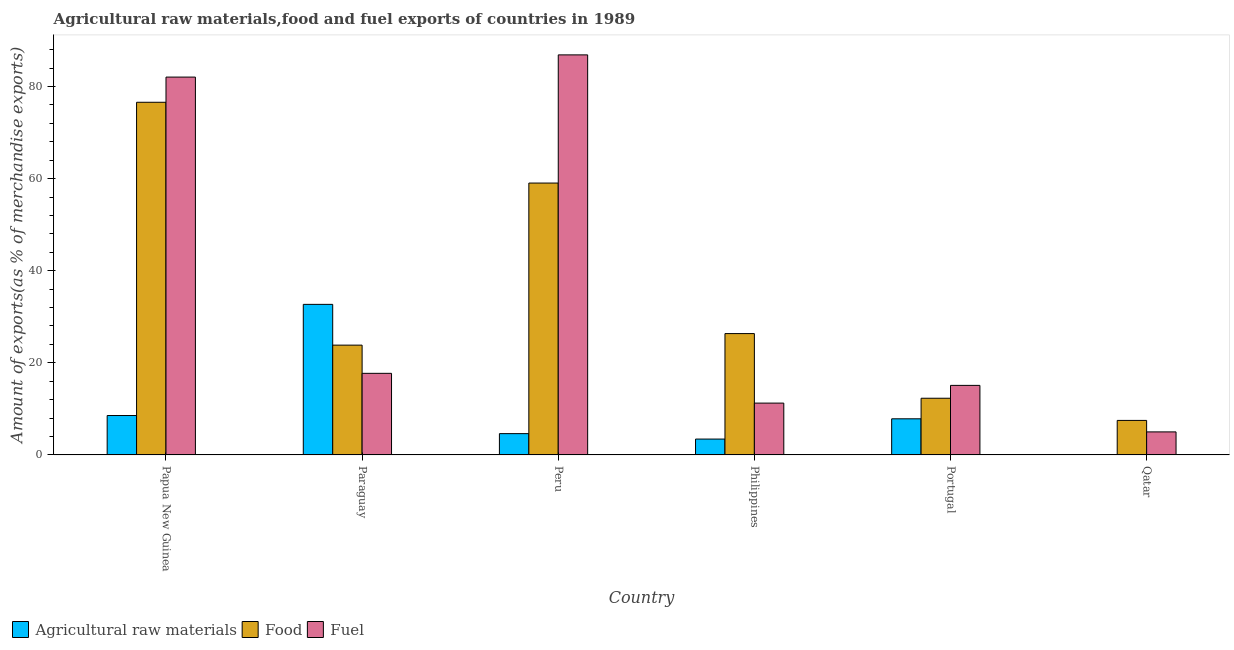How many different coloured bars are there?
Ensure brevity in your answer.  3. Are the number of bars per tick equal to the number of legend labels?
Offer a terse response. Yes. How many bars are there on the 2nd tick from the right?
Your answer should be very brief. 3. What is the label of the 1st group of bars from the left?
Your answer should be compact. Papua New Guinea. In how many cases, is the number of bars for a given country not equal to the number of legend labels?
Your answer should be compact. 0. What is the percentage of food exports in Peru?
Your answer should be compact. 59.04. Across all countries, what is the maximum percentage of food exports?
Give a very brief answer. 76.58. Across all countries, what is the minimum percentage of raw materials exports?
Make the answer very short. 0.07. In which country was the percentage of fuel exports maximum?
Your answer should be compact. Peru. In which country was the percentage of food exports minimum?
Give a very brief answer. Qatar. What is the total percentage of fuel exports in the graph?
Your answer should be very brief. 217.99. What is the difference between the percentage of raw materials exports in Peru and that in Qatar?
Keep it short and to the point. 4.55. What is the difference between the percentage of raw materials exports in Qatar and the percentage of food exports in Papua New Guinea?
Make the answer very short. -76.51. What is the average percentage of fuel exports per country?
Provide a succinct answer. 36.33. What is the difference between the percentage of raw materials exports and percentage of fuel exports in Paraguay?
Provide a succinct answer. 14.98. In how many countries, is the percentage of fuel exports greater than 80 %?
Your response must be concise. 2. What is the ratio of the percentage of fuel exports in Papua New Guinea to that in Philippines?
Provide a short and direct response. 7.29. Is the percentage of fuel exports in Peru less than that in Qatar?
Provide a short and direct response. No. Is the difference between the percentage of food exports in Papua New Guinea and Peru greater than the difference between the percentage of raw materials exports in Papua New Guinea and Peru?
Keep it short and to the point. Yes. What is the difference between the highest and the second highest percentage of raw materials exports?
Your answer should be compact. 24.14. What is the difference between the highest and the lowest percentage of raw materials exports?
Offer a terse response. 32.62. What does the 1st bar from the left in Peru represents?
Ensure brevity in your answer.  Agricultural raw materials. What does the 3rd bar from the right in Qatar represents?
Your answer should be compact. Agricultural raw materials. Is it the case that in every country, the sum of the percentage of raw materials exports and percentage of food exports is greater than the percentage of fuel exports?
Your response must be concise. No. Are all the bars in the graph horizontal?
Provide a succinct answer. No. How many countries are there in the graph?
Give a very brief answer. 6. Does the graph contain grids?
Your response must be concise. No. How many legend labels are there?
Ensure brevity in your answer.  3. How are the legend labels stacked?
Your answer should be very brief. Horizontal. What is the title of the graph?
Your response must be concise. Agricultural raw materials,food and fuel exports of countries in 1989. Does "Neonatal" appear as one of the legend labels in the graph?
Your answer should be very brief. No. What is the label or title of the Y-axis?
Provide a short and direct response. Amount of exports(as % of merchandise exports). What is the Amount of exports(as % of merchandise exports) in Agricultural raw materials in Papua New Guinea?
Offer a very short reply. 8.56. What is the Amount of exports(as % of merchandise exports) in Food in Papua New Guinea?
Your answer should be very brief. 76.58. What is the Amount of exports(as % of merchandise exports) of Fuel in Papua New Guinea?
Provide a succinct answer. 82.05. What is the Amount of exports(as % of merchandise exports) in Agricultural raw materials in Paraguay?
Your response must be concise. 32.69. What is the Amount of exports(as % of merchandise exports) of Food in Paraguay?
Your response must be concise. 23.84. What is the Amount of exports(as % of merchandise exports) in Fuel in Paraguay?
Offer a terse response. 17.72. What is the Amount of exports(as % of merchandise exports) in Agricultural raw materials in Peru?
Offer a terse response. 4.63. What is the Amount of exports(as % of merchandise exports) in Food in Peru?
Provide a succinct answer. 59.04. What is the Amount of exports(as % of merchandise exports) in Fuel in Peru?
Ensure brevity in your answer.  86.87. What is the Amount of exports(as % of merchandise exports) in Agricultural raw materials in Philippines?
Give a very brief answer. 3.44. What is the Amount of exports(as % of merchandise exports) in Food in Philippines?
Your answer should be compact. 26.35. What is the Amount of exports(as % of merchandise exports) in Fuel in Philippines?
Your response must be concise. 11.25. What is the Amount of exports(as % of merchandise exports) of Agricultural raw materials in Portugal?
Keep it short and to the point. 7.85. What is the Amount of exports(as % of merchandise exports) in Food in Portugal?
Ensure brevity in your answer.  12.31. What is the Amount of exports(as % of merchandise exports) of Fuel in Portugal?
Your answer should be compact. 15.1. What is the Amount of exports(as % of merchandise exports) of Agricultural raw materials in Qatar?
Offer a terse response. 0.07. What is the Amount of exports(as % of merchandise exports) in Food in Qatar?
Offer a very short reply. 7.5. What is the Amount of exports(as % of merchandise exports) in Fuel in Qatar?
Give a very brief answer. 5. Across all countries, what is the maximum Amount of exports(as % of merchandise exports) of Agricultural raw materials?
Keep it short and to the point. 32.69. Across all countries, what is the maximum Amount of exports(as % of merchandise exports) of Food?
Provide a succinct answer. 76.58. Across all countries, what is the maximum Amount of exports(as % of merchandise exports) of Fuel?
Ensure brevity in your answer.  86.87. Across all countries, what is the minimum Amount of exports(as % of merchandise exports) in Agricultural raw materials?
Offer a terse response. 0.07. Across all countries, what is the minimum Amount of exports(as % of merchandise exports) in Food?
Keep it short and to the point. 7.5. Across all countries, what is the minimum Amount of exports(as % of merchandise exports) in Fuel?
Offer a very short reply. 5. What is the total Amount of exports(as % of merchandise exports) in Agricultural raw materials in the graph?
Your response must be concise. 57.24. What is the total Amount of exports(as % of merchandise exports) of Food in the graph?
Your answer should be compact. 205.62. What is the total Amount of exports(as % of merchandise exports) in Fuel in the graph?
Provide a succinct answer. 217.99. What is the difference between the Amount of exports(as % of merchandise exports) of Agricultural raw materials in Papua New Guinea and that in Paraguay?
Your answer should be very brief. -24.14. What is the difference between the Amount of exports(as % of merchandise exports) of Food in Papua New Guinea and that in Paraguay?
Your answer should be compact. 52.73. What is the difference between the Amount of exports(as % of merchandise exports) in Fuel in Papua New Guinea and that in Paraguay?
Offer a terse response. 64.33. What is the difference between the Amount of exports(as % of merchandise exports) in Agricultural raw materials in Papua New Guinea and that in Peru?
Offer a very short reply. 3.93. What is the difference between the Amount of exports(as % of merchandise exports) of Food in Papua New Guinea and that in Peru?
Give a very brief answer. 17.54. What is the difference between the Amount of exports(as % of merchandise exports) in Fuel in Papua New Guinea and that in Peru?
Make the answer very short. -4.82. What is the difference between the Amount of exports(as % of merchandise exports) in Agricultural raw materials in Papua New Guinea and that in Philippines?
Give a very brief answer. 5.11. What is the difference between the Amount of exports(as % of merchandise exports) of Food in Papua New Guinea and that in Philippines?
Your answer should be very brief. 50.23. What is the difference between the Amount of exports(as % of merchandise exports) of Fuel in Papua New Guinea and that in Philippines?
Your response must be concise. 70.79. What is the difference between the Amount of exports(as % of merchandise exports) in Agricultural raw materials in Papua New Guinea and that in Portugal?
Provide a succinct answer. 0.71. What is the difference between the Amount of exports(as % of merchandise exports) in Food in Papua New Guinea and that in Portugal?
Make the answer very short. 64.27. What is the difference between the Amount of exports(as % of merchandise exports) of Fuel in Papua New Guinea and that in Portugal?
Your answer should be very brief. 66.94. What is the difference between the Amount of exports(as % of merchandise exports) in Agricultural raw materials in Papua New Guinea and that in Qatar?
Give a very brief answer. 8.48. What is the difference between the Amount of exports(as % of merchandise exports) of Food in Papua New Guinea and that in Qatar?
Your answer should be very brief. 69.08. What is the difference between the Amount of exports(as % of merchandise exports) in Fuel in Papua New Guinea and that in Qatar?
Give a very brief answer. 77.04. What is the difference between the Amount of exports(as % of merchandise exports) of Agricultural raw materials in Paraguay and that in Peru?
Your answer should be very brief. 28.07. What is the difference between the Amount of exports(as % of merchandise exports) of Food in Paraguay and that in Peru?
Offer a very short reply. -35.19. What is the difference between the Amount of exports(as % of merchandise exports) in Fuel in Paraguay and that in Peru?
Offer a very short reply. -69.15. What is the difference between the Amount of exports(as % of merchandise exports) in Agricultural raw materials in Paraguay and that in Philippines?
Your answer should be very brief. 29.25. What is the difference between the Amount of exports(as % of merchandise exports) in Food in Paraguay and that in Philippines?
Offer a terse response. -2.51. What is the difference between the Amount of exports(as % of merchandise exports) in Fuel in Paraguay and that in Philippines?
Offer a very short reply. 6.46. What is the difference between the Amount of exports(as % of merchandise exports) of Agricultural raw materials in Paraguay and that in Portugal?
Provide a succinct answer. 24.85. What is the difference between the Amount of exports(as % of merchandise exports) in Food in Paraguay and that in Portugal?
Your answer should be compact. 11.53. What is the difference between the Amount of exports(as % of merchandise exports) in Fuel in Paraguay and that in Portugal?
Keep it short and to the point. 2.61. What is the difference between the Amount of exports(as % of merchandise exports) of Agricultural raw materials in Paraguay and that in Qatar?
Give a very brief answer. 32.62. What is the difference between the Amount of exports(as % of merchandise exports) in Food in Paraguay and that in Qatar?
Your answer should be compact. 16.35. What is the difference between the Amount of exports(as % of merchandise exports) of Fuel in Paraguay and that in Qatar?
Your response must be concise. 12.71. What is the difference between the Amount of exports(as % of merchandise exports) of Agricultural raw materials in Peru and that in Philippines?
Your answer should be compact. 1.18. What is the difference between the Amount of exports(as % of merchandise exports) in Food in Peru and that in Philippines?
Offer a terse response. 32.68. What is the difference between the Amount of exports(as % of merchandise exports) in Fuel in Peru and that in Philippines?
Ensure brevity in your answer.  75.62. What is the difference between the Amount of exports(as % of merchandise exports) in Agricultural raw materials in Peru and that in Portugal?
Keep it short and to the point. -3.22. What is the difference between the Amount of exports(as % of merchandise exports) in Food in Peru and that in Portugal?
Keep it short and to the point. 46.73. What is the difference between the Amount of exports(as % of merchandise exports) in Fuel in Peru and that in Portugal?
Provide a short and direct response. 71.77. What is the difference between the Amount of exports(as % of merchandise exports) of Agricultural raw materials in Peru and that in Qatar?
Offer a very short reply. 4.55. What is the difference between the Amount of exports(as % of merchandise exports) in Food in Peru and that in Qatar?
Offer a very short reply. 51.54. What is the difference between the Amount of exports(as % of merchandise exports) of Fuel in Peru and that in Qatar?
Provide a succinct answer. 81.87. What is the difference between the Amount of exports(as % of merchandise exports) of Agricultural raw materials in Philippines and that in Portugal?
Your answer should be compact. -4.4. What is the difference between the Amount of exports(as % of merchandise exports) in Food in Philippines and that in Portugal?
Provide a succinct answer. 14.04. What is the difference between the Amount of exports(as % of merchandise exports) of Fuel in Philippines and that in Portugal?
Provide a short and direct response. -3.85. What is the difference between the Amount of exports(as % of merchandise exports) of Agricultural raw materials in Philippines and that in Qatar?
Your answer should be very brief. 3.37. What is the difference between the Amount of exports(as % of merchandise exports) of Food in Philippines and that in Qatar?
Keep it short and to the point. 18.85. What is the difference between the Amount of exports(as % of merchandise exports) of Fuel in Philippines and that in Qatar?
Offer a very short reply. 6.25. What is the difference between the Amount of exports(as % of merchandise exports) in Agricultural raw materials in Portugal and that in Qatar?
Offer a very short reply. 7.77. What is the difference between the Amount of exports(as % of merchandise exports) in Food in Portugal and that in Qatar?
Your answer should be very brief. 4.81. What is the difference between the Amount of exports(as % of merchandise exports) of Fuel in Portugal and that in Qatar?
Your answer should be compact. 10.1. What is the difference between the Amount of exports(as % of merchandise exports) of Agricultural raw materials in Papua New Guinea and the Amount of exports(as % of merchandise exports) of Food in Paraguay?
Make the answer very short. -15.29. What is the difference between the Amount of exports(as % of merchandise exports) of Agricultural raw materials in Papua New Guinea and the Amount of exports(as % of merchandise exports) of Fuel in Paraguay?
Make the answer very short. -9.16. What is the difference between the Amount of exports(as % of merchandise exports) of Food in Papua New Guinea and the Amount of exports(as % of merchandise exports) of Fuel in Paraguay?
Offer a very short reply. 58.86. What is the difference between the Amount of exports(as % of merchandise exports) in Agricultural raw materials in Papua New Guinea and the Amount of exports(as % of merchandise exports) in Food in Peru?
Ensure brevity in your answer.  -50.48. What is the difference between the Amount of exports(as % of merchandise exports) in Agricultural raw materials in Papua New Guinea and the Amount of exports(as % of merchandise exports) in Fuel in Peru?
Make the answer very short. -78.31. What is the difference between the Amount of exports(as % of merchandise exports) in Food in Papua New Guinea and the Amount of exports(as % of merchandise exports) in Fuel in Peru?
Offer a very short reply. -10.29. What is the difference between the Amount of exports(as % of merchandise exports) in Agricultural raw materials in Papua New Guinea and the Amount of exports(as % of merchandise exports) in Food in Philippines?
Your response must be concise. -17.79. What is the difference between the Amount of exports(as % of merchandise exports) of Agricultural raw materials in Papua New Guinea and the Amount of exports(as % of merchandise exports) of Fuel in Philippines?
Provide a succinct answer. -2.7. What is the difference between the Amount of exports(as % of merchandise exports) of Food in Papua New Guinea and the Amount of exports(as % of merchandise exports) of Fuel in Philippines?
Ensure brevity in your answer.  65.33. What is the difference between the Amount of exports(as % of merchandise exports) of Agricultural raw materials in Papua New Guinea and the Amount of exports(as % of merchandise exports) of Food in Portugal?
Make the answer very short. -3.75. What is the difference between the Amount of exports(as % of merchandise exports) of Agricultural raw materials in Papua New Guinea and the Amount of exports(as % of merchandise exports) of Fuel in Portugal?
Offer a very short reply. -6.55. What is the difference between the Amount of exports(as % of merchandise exports) of Food in Papua New Guinea and the Amount of exports(as % of merchandise exports) of Fuel in Portugal?
Your answer should be compact. 61.48. What is the difference between the Amount of exports(as % of merchandise exports) of Agricultural raw materials in Papua New Guinea and the Amount of exports(as % of merchandise exports) of Food in Qatar?
Offer a very short reply. 1.06. What is the difference between the Amount of exports(as % of merchandise exports) of Agricultural raw materials in Papua New Guinea and the Amount of exports(as % of merchandise exports) of Fuel in Qatar?
Give a very brief answer. 3.55. What is the difference between the Amount of exports(as % of merchandise exports) of Food in Papua New Guinea and the Amount of exports(as % of merchandise exports) of Fuel in Qatar?
Your answer should be compact. 71.58. What is the difference between the Amount of exports(as % of merchandise exports) in Agricultural raw materials in Paraguay and the Amount of exports(as % of merchandise exports) in Food in Peru?
Your answer should be compact. -26.34. What is the difference between the Amount of exports(as % of merchandise exports) of Agricultural raw materials in Paraguay and the Amount of exports(as % of merchandise exports) of Fuel in Peru?
Keep it short and to the point. -54.18. What is the difference between the Amount of exports(as % of merchandise exports) of Food in Paraguay and the Amount of exports(as % of merchandise exports) of Fuel in Peru?
Offer a terse response. -63.03. What is the difference between the Amount of exports(as % of merchandise exports) in Agricultural raw materials in Paraguay and the Amount of exports(as % of merchandise exports) in Food in Philippines?
Keep it short and to the point. 6.34. What is the difference between the Amount of exports(as % of merchandise exports) of Agricultural raw materials in Paraguay and the Amount of exports(as % of merchandise exports) of Fuel in Philippines?
Give a very brief answer. 21.44. What is the difference between the Amount of exports(as % of merchandise exports) in Food in Paraguay and the Amount of exports(as % of merchandise exports) in Fuel in Philippines?
Offer a terse response. 12.59. What is the difference between the Amount of exports(as % of merchandise exports) of Agricultural raw materials in Paraguay and the Amount of exports(as % of merchandise exports) of Food in Portugal?
Make the answer very short. 20.38. What is the difference between the Amount of exports(as % of merchandise exports) in Agricultural raw materials in Paraguay and the Amount of exports(as % of merchandise exports) in Fuel in Portugal?
Your answer should be very brief. 17.59. What is the difference between the Amount of exports(as % of merchandise exports) of Food in Paraguay and the Amount of exports(as % of merchandise exports) of Fuel in Portugal?
Offer a terse response. 8.74. What is the difference between the Amount of exports(as % of merchandise exports) of Agricultural raw materials in Paraguay and the Amount of exports(as % of merchandise exports) of Food in Qatar?
Offer a very short reply. 25.2. What is the difference between the Amount of exports(as % of merchandise exports) in Agricultural raw materials in Paraguay and the Amount of exports(as % of merchandise exports) in Fuel in Qatar?
Provide a succinct answer. 27.69. What is the difference between the Amount of exports(as % of merchandise exports) in Food in Paraguay and the Amount of exports(as % of merchandise exports) in Fuel in Qatar?
Your response must be concise. 18.84. What is the difference between the Amount of exports(as % of merchandise exports) in Agricultural raw materials in Peru and the Amount of exports(as % of merchandise exports) in Food in Philippines?
Your answer should be very brief. -21.73. What is the difference between the Amount of exports(as % of merchandise exports) in Agricultural raw materials in Peru and the Amount of exports(as % of merchandise exports) in Fuel in Philippines?
Provide a succinct answer. -6.63. What is the difference between the Amount of exports(as % of merchandise exports) of Food in Peru and the Amount of exports(as % of merchandise exports) of Fuel in Philippines?
Your answer should be compact. 47.78. What is the difference between the Amount of exports(as % of merchandise exports) of Agricultural raw materials in Peru and the Amount of exports(as % of merchandise exports) of Food in Portugal?
Your answer should be compact. -7.68. What is the difference between the Amount of exports(as % of merchandise exports) in Agricultural raw materials in Peru and the Amount of exports(as % of merchandise exports) in Fuel in Portugal?
Your response must be concise. -10.48. What is the difference between the Amount of exports(as % of merchandise exports) in Food in Peru and the Amount of exports(as % of merchandise exports) in Fuel in Portugal?
Ensure brevity in your answer.  43.93. What is the difference between the Amount of exports(as % of merchandise exports) of Agricultural raw materials in Peru and the Amount of exports(as % of merchandise exports) of Food in Qatar?
Your answer should be very brief. -2.87. What is the difference between the Amount of exports(as % of merchandise exports) of Agricultural raw materials in Peru and the Amount of exports(as % of merchandise exports) of Fuel in Qatar?
Keep it short and to the point. -0.38. What is the difference between the Amount of exports(as % of merchandise exports) of Food in Peru and the Amount of exports(as % of merchandise exports) of Fuel in Qatar?
Offer a very short reply. 54.03. What is the difference between the Amount of exports(as % of merchandise exports) of Agricultural raw materials in Philippines and the Amount of exports(as % of merchandise exports) of Food in Portugal?
Make the answer very short. -8.87. What is the difference between the Amount of exports(as % of merchandise exports) in Agricultural raw materials in Philippines and the Amount of exports(as % of merchandise exports) in Fuel in Portugal?
Provide a short and direct response. -11.66. What is the difference between the Amount of exports(as % of merchandise exports) of Food in Philippines and the Amount of exports(as % of merchandise exports) of Fuel in Portugal?
Provide a short and direct response. 11.25. What is the difference between the Amount of exports(as % of merchandise exports) in Agricultural raw materials in Philippines and the Amount of exports(as % of merchandise exports) in Food in Qatar?
Provide a succinct answer. -4.05. What is the difference between the Amount of exports(as % of merchandise exports) of Agricultural raw materials in Philippines and the Amount of exports(as % of merchandise exports) of Fuel in Qatar?
Your response must be concise. -1.56. What is the difference between the Amount of exports(as % of merchandise exports) in Food in Philippines and the Amount of exports(as % of merchandise exports) in Fuel in Qatar?
Make the answer very short. 21.35. What is the difference between the Amount of exports(as % of merchandise exports) in Agricultural raw materials in Portugal and the Amount of exports(as % of merchandise exports) in Food in Qatar?
Provide a succinct answer. 0.35. What is the difference between the Amount of exports(as % of merchandise exports) in Agricultural raw materials in Portugal and the Amount of exports(as % of merchandise exports) in Fuel in Qatar?
Provide a succinct answer. 2.84. What is the difference between the Amount of exports(as % of merchandise exports) of Food in Portugal and the Amount of exports(as % of merchandise exports) of Fuel in Qatar?
Your response must be concise. 7.31. What is the average Amount of exports(as % of merchandise exports) of Agricultural raw materials per country?
Your response must be concise. 9.54. What is the average Amount of exports(as % of merchandise exports) in Food per country?
Your answer should be compact. 34.27. What is the average Amount of exports(as % of merchandise exports) of Fuel per country?
Keep it short and to the point. 36.33. What is the difference between the Amount of exports(as % of merchandise exports) of Agricultural raw materials and Amount of exports(as % of merchandise exports) of Food in Papua New Guinea?
Your response must be concise. -68.02. What is the difference between the Amount of exports(as % of merchandise exports) in Agricultural raw materials and Amount of exports(as % of merchandise exports) in Fuel in Papua New Guinea?
Keep it short and to the point. -73.49. What is the difference between the Amount of exports(as % of merchandise exports) in Food and Amount of exports(as % of merchandise exports) in Fuel in Papua New Guinea?
Your response must be concise. -5.47. What is the difference between the Amount of exports(as % of merchandise exports) of Agricultural raw materials and Amount of exports(as % of merchandise exports) of Food in Paraguay?
Give a very brief answer. 8.85. What is the difference between the Amount of exports(as % of merchandise exports) in Agricultural raw materials and Amount of exports(as % of merchandise exports) in Fuel in Paraguay?
Provide a succinct answer. 14.98. What is the difference between the Amount of exports(as % of merchandise exports) of Food and Amount of exports(as % of merchandise exports) of Fuel in Paraguay?
Provide a succinct answer. 6.13. What is the difference between the Amount of exports(as % of merchandise exports) of Agricultural raw materials and Amount of exports(as % of merchandise exports) of Food in Peru?
Provide a short and direct response. -54.41. What is the difference between the Amount of exports(as % of merchandise exports) of Agricultural raw materials and Amount of exports(as % of merchandise exports) of Fuel in Peru?
Make the answer very short. -82.24. What is the difference between the Amount of exports(as % of merchandise exports) in Food and Amount of exports(as % of merchandise exports) in Fuel in Peru?
Provide a succinct answer. -27.83. What is the difference between the Amount of exports(as % of merchandise exports) of Agricultural raw materials and Amount of exports(as % of merchandise exports) of Food in Philippines?
Ensure brevity in your answer.  -22.91. What is the difference between the Amount of exports(as % of merchandise exports) of Agricultural raw materials and Amount of exports(as % of merchandise exports) of Fuel in Philippines?
Offer a very short reply. -7.81. What is the difference between the Amount of exports(as % of merchandise exports) in Food and Amount of exports(as % of merchandise exports) in Fuel in Philippines?
Offer a terse response. 15.1. What is the difference between the Amount of exports(as % of merchandise exports) of Agricultural raw materials and Amount of exports(as % of merchandise exports) of Food in Portugal?
Offer a very short reply. -4.46. What is the difference between the Amount of exports(as % of merchandise exports) in Agricultural raw materials and Amount of exports(as % of merchandise exports) in Fuel in Portugal?
Your response must be concise. -7.26. What is the difference between the Amount of exports(as % of merchandise exports) of Food and Amount of exports(as % of merchandise exports) of Fuel in Portugal?
Your answer should be very brief. -2.79. What is the difference between the Amount of exports(as % of merchandise exports) in Agricultural raw materials and Amount of exports(as % of merchandise exports) in Food in Qatar?
Provide a short and direct response. -7.42. What is the difference between the Amount of exports(as % of merchandise exports) of Agricultural raw materials and Amount of exports(as % of merchandise exports) of Fuel in Qatar?
Provide a succinct answer. -4.93. What is the difference between the Amount of exports(as % of merchandise exports) in Food and Amount of exports(as % of merchandise exports) in Fuel in Qatar?
Make the answer very short. 2.49. What is the ratio of the Amount of exports(as % of merchandise exports) in Agricultural raw materials in Papua New Guinea to that in Paraguay?
Offer a terse response. 0.26. What is the ratio of the Amount of exports(as % of merchandise exports) in Food in Papua New Guinea to that in Paraguay?
Your response must be concise. 3.21. What is the ratio of the Amount of exports(as % of merchandise exports) of Fuel in Papua New Guinea to that in Paraguay?
Your response must be concise. 4.63. What is the ratio of the Amount of exports(as % of merchandise exports) of Agricultural raw materials in Papua New Guinea to that in Peru?
Make the answer very short. 1.85. What is the ratio of the Amount of exports(as % of merchandise exports) in Food in Papua New Guinea to that in Peru?
Your answer should be very brief. 1.3. What is the ratio of the Amount of exports(as % of merchandise exports) of Fuel in Papua New Guinea to that in Peru?
Provide a succinct answer. 0.94. What is the ratio of the Amount of exports(as % of merchandise exports) in Agricultural raw materials in Papua New Guinea to that in Philippines?
Make the answer very short. 2.49. What is the ratio of the Amount of exports(as % of merchandise exports) in Food in Papua New Guinea to that in Philippines?
Keep it short and to the point. 2.91. What is the ratio of the Amount of exports(as % of merchandise exports) of Fuel in Papua New Guinea to that in Philippines?
Make the answer very short. 7.29. What is the ratio of the Amount of exports(as % of merchandise exports) of Agricultural raw materials in Papua New Guinea to that in Portugal?
Your answer should be compact. 1.09. What is the ratio of the Amount of exports(as % of merchandise exports) in Food in Papua New Guinea to that in Portugal?
Provide a short and direct response. 6.22. What is the ratio of the Amount of exports(as % of merchandise exports) of Fuel in Papua New Guinea to that in Portugal?
Offer a terse response. 5.43. What is the ratio of the Amount of exports(as % of merchandise exports) of Agricultural raw materials in Papua New Guinea to that in Qatar?
Offer a terse response. 116.97. What is the ratio of the Amount of exports(as % of merchandise exports) in Food in Papua New Guinea to that in Qatar?
Your answer should be compact. 10.22. What is the ratio of the Amount of exports(as % of merchandise exports) of Fuel in Papua New Guinea to that in Qatar?
Offer a terse response. 16.4. What is the ratio of the Amount of exports(as % of merchandise exports) in Agricultural raw materials in Paraguay to that in Peru?
Your response must be concise. 7.07. What is the ratio of the Amount of exports(as % of merchandise exports) of Food in Paraguay to that in Peru?
Give a very brief answer. 0.4. What is the ratio of the Amount of exports(as % of merchandise exports) of Fuel in Paraguay to that in Peru?
Keep it short and to the point. 0.2. What is the ratio of the Amount of exports(as % of merchandise exports) in Agricultural raw materials in Paraguay to that in Philippines?
Ensure brevity in your answer.  9.5. What is the ratio of the Amount of exports(as % of merchandise exports) in Food in Paraguay to that in Philippines?
Your answer should be compact. 0.9. What is the ratio of the Amount of exports(as % of merchandise exports) of Fuel in Paraguay to that in Philippines?
Give a very brief answer. 1.57. What is the ratio of the Amount of exports(as % of merchandise exports) in Agricultural raw materials in Paraguay to that in Portugal?
Give a very brief answer. 4.17. What is the ratio of the Amount of exports(as % of merchandise exports) in Food in Paraguay to that in Portugal?
Make the answer very short. 1.94. What is the ratio of the Amount of exports(as % of merchandise exports) in Fuel in Paraguay to that in Portugal?
Keep it short and to the point. 1.17. What is the ratio of the Amount of exports(as % of merchandise exports) of Agricultural raw materials in Paraguay to that in Qatar?
Offer a terse response. 446.92. What is the ratio of the Amount of exports(as % of merchandise exports) in Food in Paraguay to that in Qatar?
Offer a terse response. 3.18. What is the ratio of the Amount of exports(as % of merchandise exports) of Fuel in Paraguay to that in Qatar?
Keep it short and to the point. 3.54. What is the ratio of the Amount of exports(as % of merchandise exports) in Agricultural raw materials in Peru to that in Philippines?
Make the answer very short. 1.34. What is the ratio of the Amount of exports(as % of merchandise exports) in Food in Peru to that in Philippines?
Keep it short and to the point. 2.24. What is the ratio of the Amount of exports(as % of merchandise exports) of Fuel in Peru to that in Philippines?
Give a very brief answer. 7.72. What is the ratio of the Amount of exports(as % of merchandise exports) of Agricultural raw materials in Peru to that in Portugal?
Provide a succinct answer. 0.59. What is the ratio of the Amount of exports(as % of merchandise exports) of Food in Peru to that in Portugal?
Your response must be concise. 4.8. What is the ratio of the Amount of exports(as % of merchandise exports) of Fuel in Peru to that in Portugal?
Make the answer very short. 5.75. What is the ratio of the Amount of exports(as % of merchandise exports) in Agricultural raw materials in Peru to that in Qatar?
Give a very brief answer. 63.24. What is the ratio of the Amount of exports(as % of merchandise exports) in Food in Peru to that in Qatar?
Your answer should be very brief. 7.88. What is the ratio of the Amount of exports(as % of merchandise exports) of Fuel in Peru to that in Qatar?
Your response must be concise. 17.36. What is the ratio of the Amount of exports(as % of merchandise exports) in Agricultural raw materials in Philippines to that in Portugal?
Offer a terse response. 0.44. What is the ratio of the Amount of exports(as % of merchandise exports) of Food in Philippines to that in Portugal?
Offer a terse response. 2.14. What is the ratio of the Amount of exports(as % of merchandise exports) in Fuel in Philippines to that in Portugal?
Your response must be concise. 0.75. What is the ratio of the Amount of exports(as % of merchandise exports) of Agricultural raw materials in Philippines to that in Qatar?
Your answer should be very brief. 47.06. What is the ratio of the Amount of exports(as % of merchandise exports) in Food in Philippines to that in Qatar?
Offer a terse response. 3.52. What is the ratio of the Amount of exports(as % of merchandise exports) in Fuel in Philippines to that in Qatar?
Your response must be concise. 2.25. What is the ratio of the Amount of exports(as % of merchandise exports) in Agricultural raw materials in Portugal to that in Qatar?
Provide a succinct answer. 107.25. What is the ratio of the Amount of exports(as % of merchandise exports) in Food in Portugal to that in Qatar?
Give a very brief answer. 1.64. What is the ratio of the Amount of exports(as % of merchandise exports) of Fuel in Portugal to that in Qatar?
Your response must be concise. 3.02. What is the difference between the highest and the second highest Amount of exports(as % of merchandise exports) in Agricultural raw materials?
Provide a succinct answer. 24.14. What is the difference between the highest and the second highest Amount of exports(as % of merchandise exports) of Food?
Provide a short and direct response. 17.54. What is the difference between the highest and the second highest Amount of exports(as % of merchandise exports) in Fuel?
Your response must be concise. 4.82. What is the difference between the highest and the lowest Amount of exports(as % of merchandise exports) in Agricultural raw materials?
Give a very brief answer. 32.62. What is the difference between the highest and the lowest Amount of exports(as % of merchandise exports) of Food?
Offer a very short reply. 69.08. What is the difference between the highest and the lowest Amount of exports(as % of merchandise exports) of Fuel?
Offer a very short reply. 81.87. 